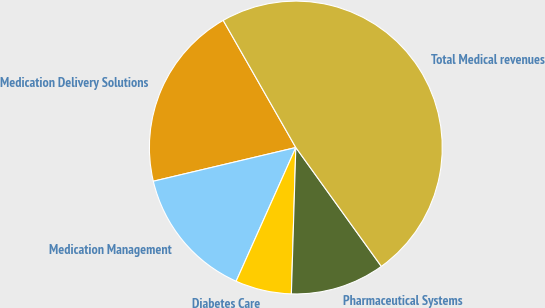<chart> <loc_0><loc_0><loc_500><loc_500><pie_chart><fcel>Medication Delivery Solutions<fcel>Medication Management<fcel>Diabetes Care<fcel>Pharmaceutical Systems<fcel>Total Medical revenues<nl><fcel>20.44%<fcel>14.62%<fcel>6.2%<fcel>10.41%<fcel>48.33%<nl></chart> 